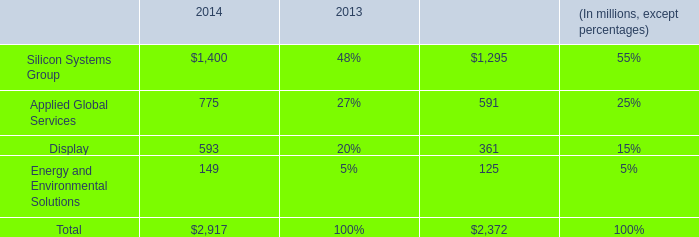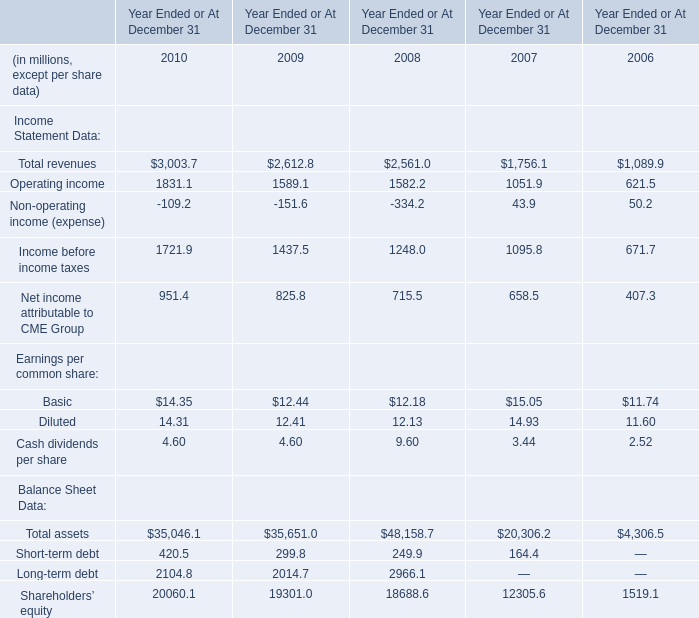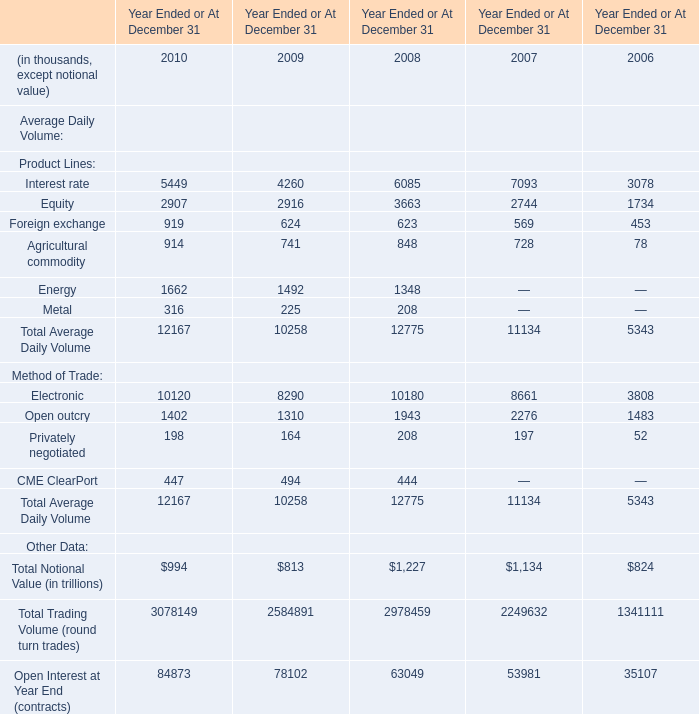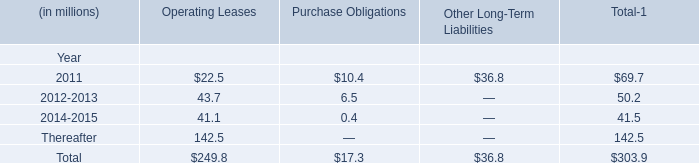What was the average of Total revenues in 2010, 2009, and 2008? (in millions) 
Computations: (((3003.7 + 2612.8) + 2561.0) / 3)
Answer: 2725.83333. 